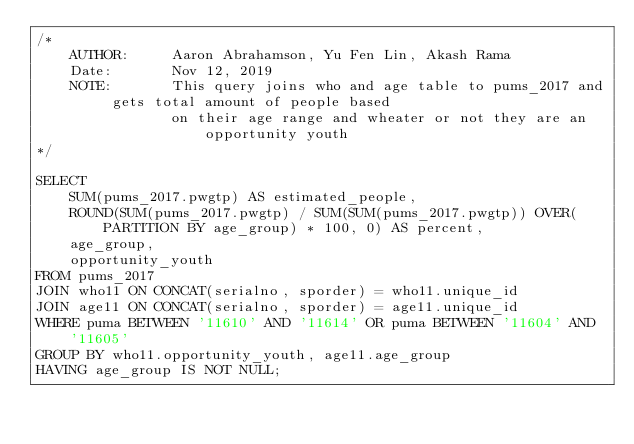<code> <loc_0><loc_0><loc_500><loc_500><_SQL_>/*  
    AUTHOR:     Aaron Abrahamson, Yu Fen Lin, Akash Rama
    Date:       Nov 12, 2019
    NOTE:       This query joins who and age table to pums_2017 and gets total amount of people based
                on their age range and wheater or not they are an opportunity youth
*/

SELECT 
    SUM(pums_2017.pwgtp) AS estimated_people, 
    ROUND(SUM(pums_2017.pwgtp) / SUM(SUM(pums_2017.pwgtp)) OVER(PARTITION BY age_group) * 100, 0) AS percent,
    age_group,
    opportunity_youth 
FROM pums_2017 
JOIN who11 ON CONCAT(serialno, sporder) = who11.unique_id
JOIN age11 ON CONCAT(serialno, sporder) = age11.unique_id
WHERE puma BETWEEN '11610' AND '11614' OR puma BETWEEN '11604' AND '11605'
GROUP BY who11.opportunity_youth, age11.age_group
HAVING age_group IS NOT NULL;
</code> 